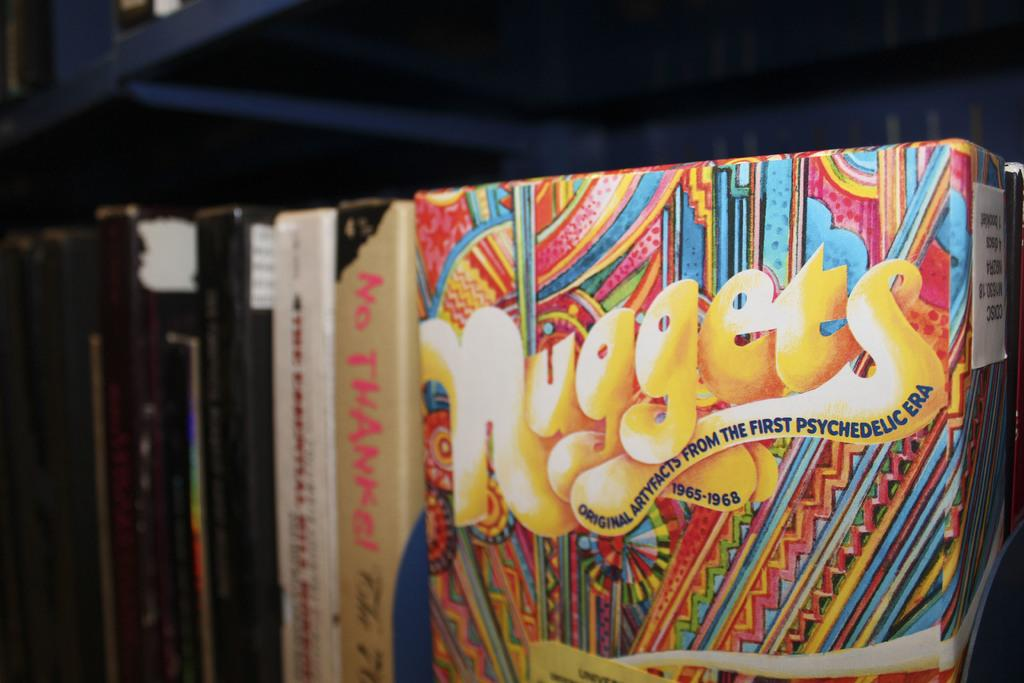<image>
Describe the image concisely. the word nuggets is on the colorful item 